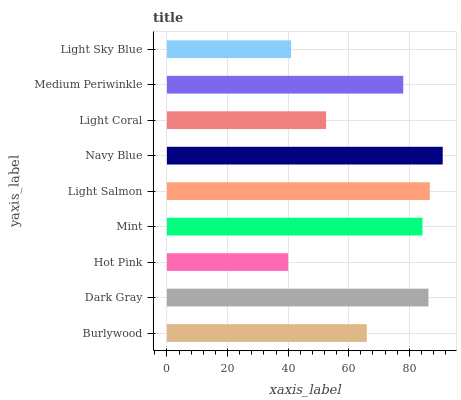Is Hot Pink the minimum?
Answer yes or no. Yes. Is Navy Blue the maximum?
Answer yes or no. Yes. Is Dark Gray the minimum?
Answer yes or no. No. Is Dark Gray the maximum?
Answer yes or no. No. Is Dark Gray greater than Burlywood?
Answer yes or no. Yes. Is Burlywood less than Dark Gray?
Answer yes or no. Yes. Is Burlywood greater than Dark Gray?
Answer yes or no. No. Is Dark Gray less than Burlywood?
Answer yes or no. No. Is Medium Periwinkle the high median?
Answer yes or no. Yes. Is Medium Periwinkle the low median?
Answer yes or no. Yes. Is Navy Blue the high median?
Answer yes or no. No. Is Mint the low median?
Answer yes or no. No. 